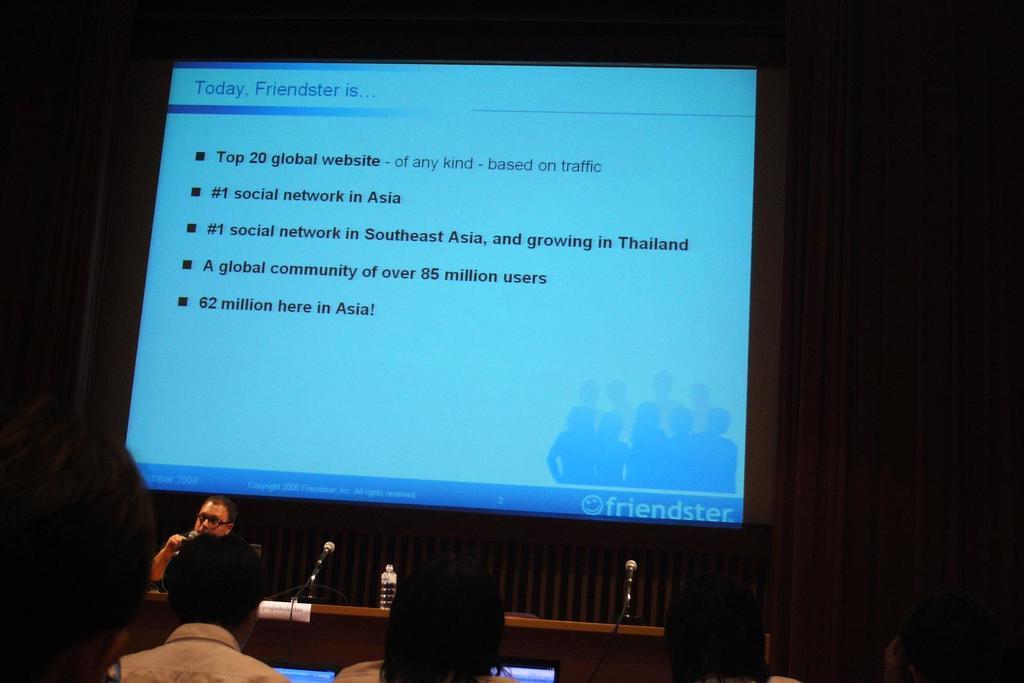In one or two sentences, can you explain what this image depicts? There are few people sitting. This is a table with a bottle and the mikes. I can see a screen with the display. The background looks dark. 